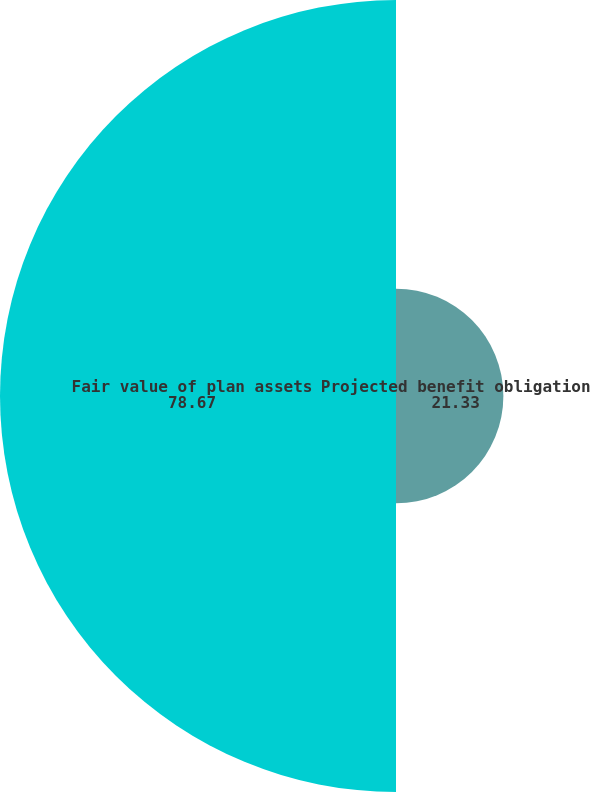Convert chart. <chart><loc_0><loc_0><loc_500><loc_500><pie_chart><fcel>Projected benefit obligation<fcel>Fair value of plan assets<nl><fcel>21.33%<fcel>78.67%<nl></chart> 